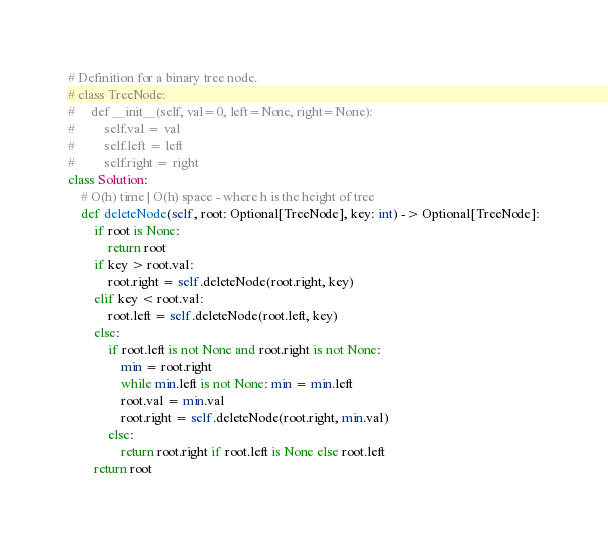Convert code to text. <code><loc_0><loc_0><loc_500><loc_500><_Python_># Definition for a binary tree node.
# class TreeNode:
#     def __init__(self, val=0, left=None, right=None):
#         self.val = val
#         self.left = left
#         self.right = right
class Solution:
    # O(h) time | O(h) space - where h is the height of tree
    def deleteNode(self, root: Optional[TreeNode], key: int) -> Optional[TreeNode]:
        if root is None:
            return root
        if key > root.val:
            root.right = self.deleteNode(root.right, key)
        elif key < root.val:
            root.left = self.deleteNode(root.left, key)
        else:
            if root.left is not None and root.right is not None:
                min = root.right
                while min.left is not None: min = min.left
                root.val = min.val
                root.right = self.deleteNode(root.right, min.val)
            else:
                return root.right if root.left is None else root.left
        return root
</code> 